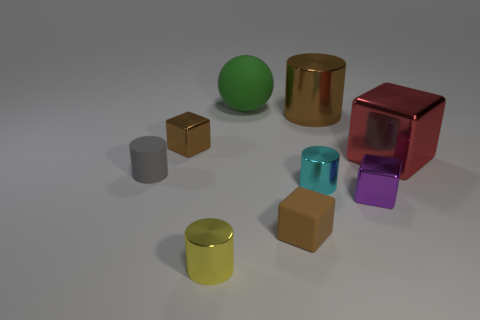Subtract all brown blocks. How many were subtracted if there are1brown blocks left? 1 Subtract 2 blocks. How many blocks are left? 2 Add 1 brown cubes. How many objects exist? 10 Subtract all yellow cubes. Subtract all gray balls. How many cubes are left? 4 Add 9 gray objects. How many gray objects exist? 10 Subtract 0 purple spheres. How many objects are left? 9 Subtract all spheres. How many objects are left? 8 Subtract all cyan metallic objects. Subtract all matte blocks. How many objects are left? 7 Add 6 small rubber objects. How many small rubber objects are left? 8 